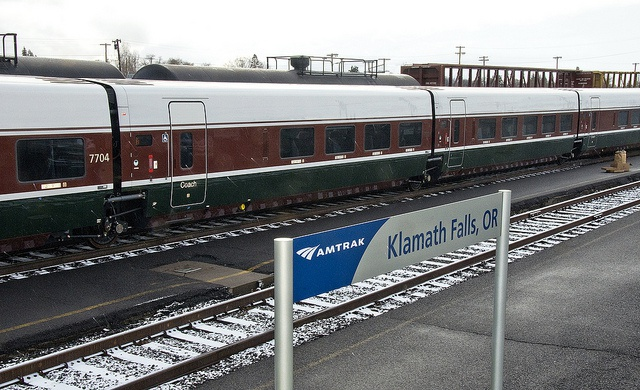Describe the objects in this image and their specific colors. I can see a train in white, black, lightgray, maroon, and gray tones in this image. 